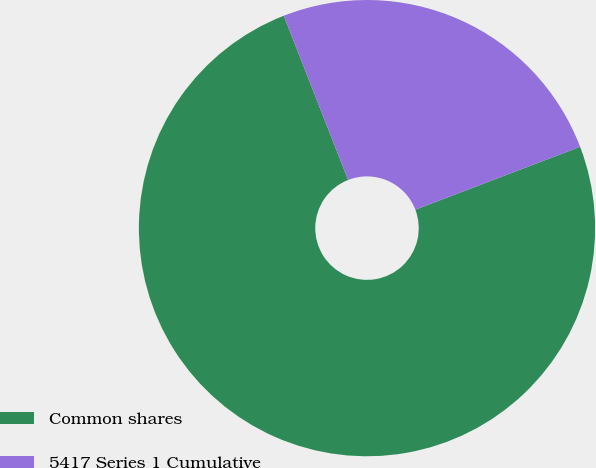Convert chart. <chart><loc_0><loc_0><loc_500><loc_500><pie_chart><fcel>Common shares<fcel>5417 Series 1 Cumulative<nl><fcel>74.86%<fcel>25.14%<nl></chart> 